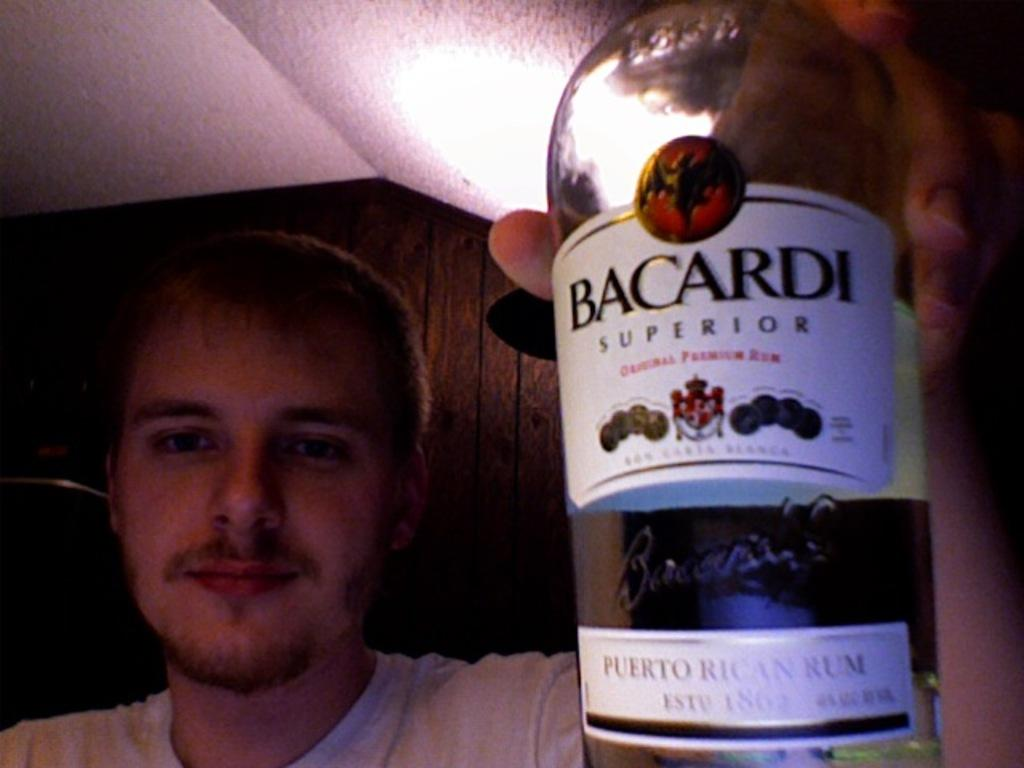<image>
Share a concise interpretation of the image provided. A man holding a bottle of rum up with a label that says on Bacardi Superior on it. 